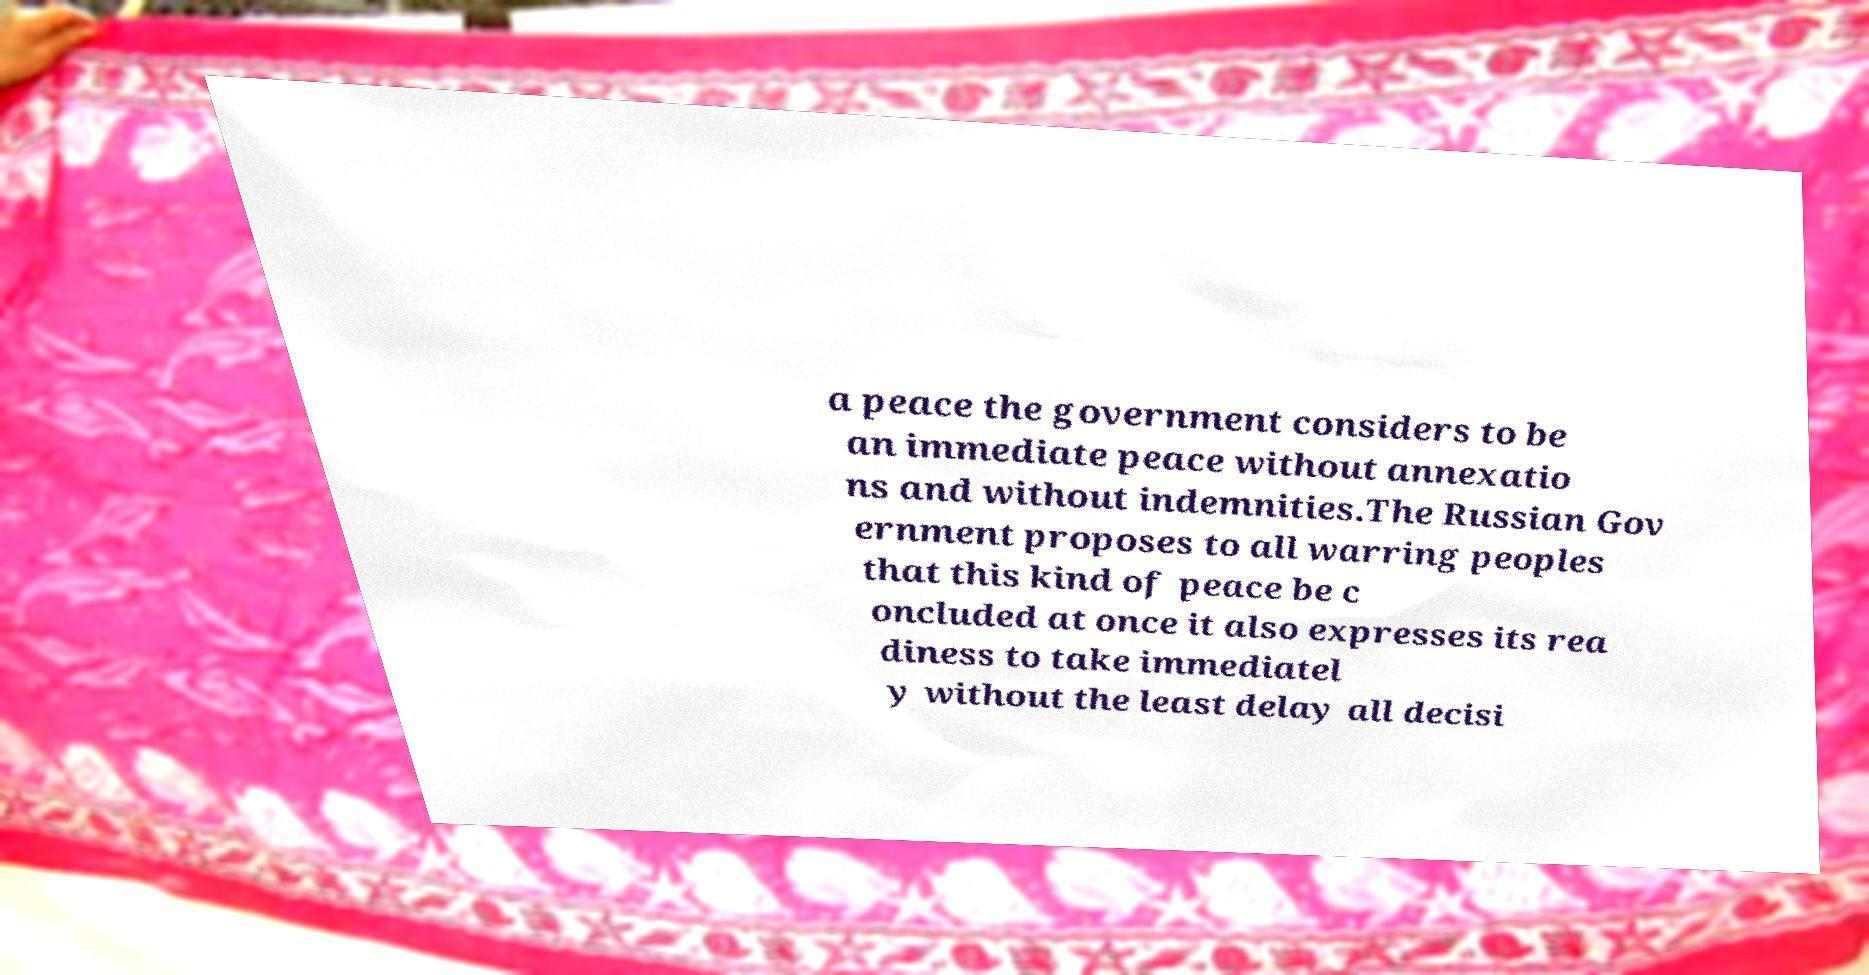Please identify and transcribe the text found in this image. a peace the government considers to be an immediate peace without annexatio ns and without indemnities.The Russian Gov ernment proposes to all warring peoples that this kind of peace be c oncluded at once it also expresses its rea diness to take immediatel y without the least delay all decisi 